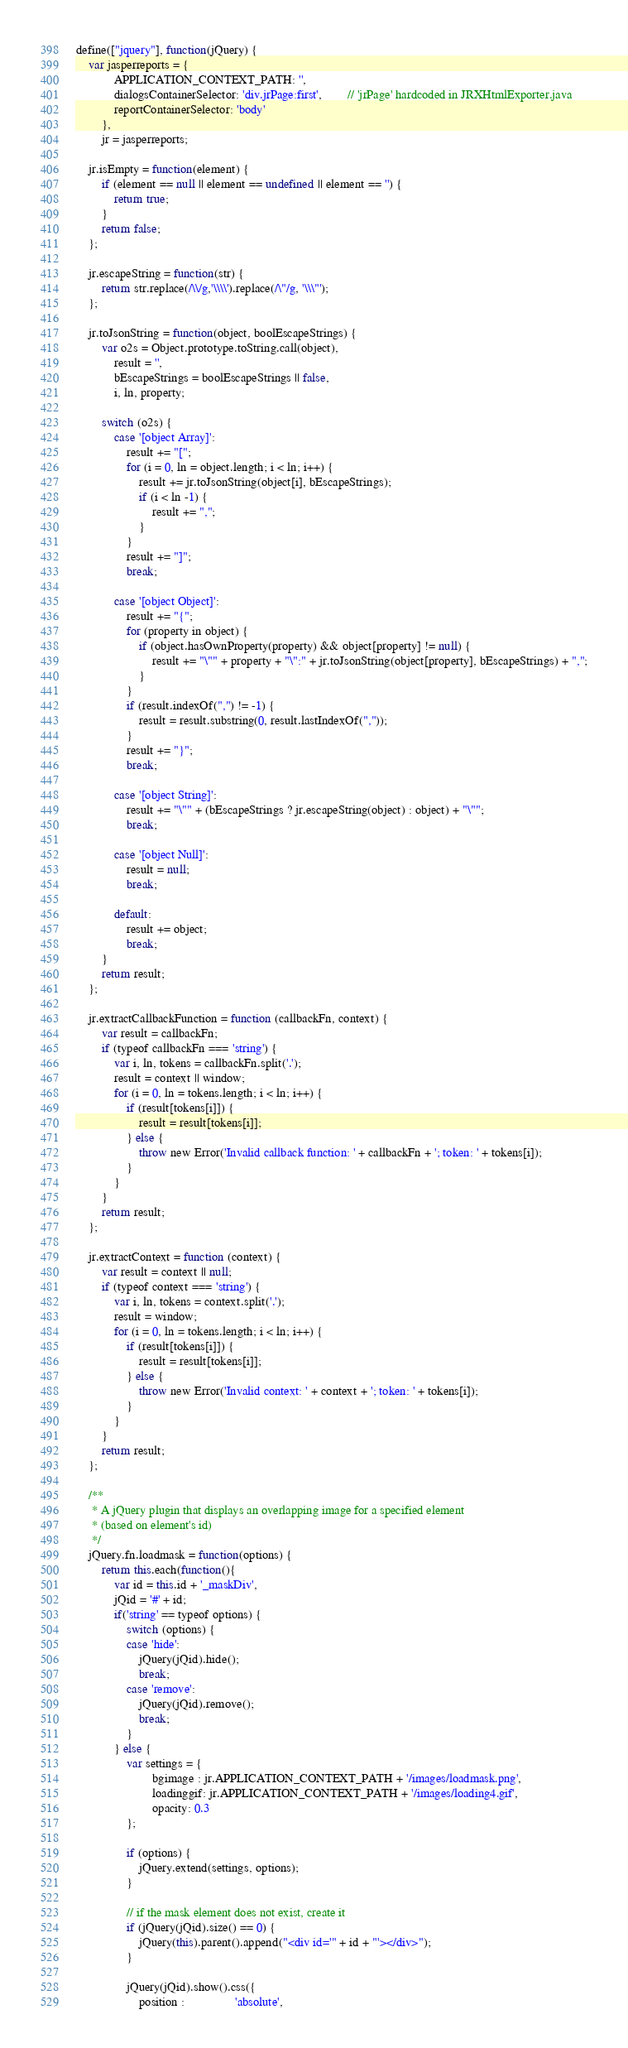Convert code to text. <code><loc_0><loc_0><loc_500><loc_500><_JavaScript_>define(["jquery"], function(jQuery) {
	var jasperreports = {
			APPLICATION_CONTEXT_PATH: '',
			dialogsContainerSelector: 'div.jrPage:first',		// 'jrPage' hardcoded in JRXHtmlExporter.java
			reportContainerSelector: 'body'
		},
		jr = jasperreports;

	jr.isEmpty = function(element) {
		if (element == null || element == undefined || element == '') {
			return true;
		}
		return false;
	};
	
	jr.escapeString = function(str) {
		return str.replace(/\\/g,'\\\\').replace(/\"/g, '\\\"');
	};
	
	jr.toJsonString = function(object, boolEscapeStrings) {
		var o2s = Object.prototype.toString.call(object),
			result = '',
			bEscapeStrings = boolEscapeStrings || false,
			i, ln, property;

		switch (o2s) {
			case '[object Array]':
				result += "[";
				for (i = 0, ln = object.length; i < ln; i++) {
					result += jr.toJsonString(object[i], bEscapeStrings);
					if (i < ln -1) {
						result += ",";
					}
				}
				result += "]";
				break;

			case '[object Object]':
				result += "{";
				for (property in object) {
					if (object.hasOwnProperty(property) && object[property] != null) {
						result += "\"" + property + "\":" + jr.toJsonString(object[property], bEscapeStrings) + ",";
					}
				}
				if (result.indexOf(",") != -1) {
					result = result.substring(0, result.lastIndexOf(","));
				}
				result += "}";
				break;

			case '[object String]':
				result += "\"" + (bEscapeStrings ? jr.escapeString(object) : object) + "\"";
				break;

			case '[object Null]':
				result = null;
				break;

			default:
				result += object;
				break;
		}
		return result;
	};
	
	jr.extractCallbackFunction = function (callbackFn, context) {
		var result = callbackFn;
		if (typeof callbackFn === 'string') {
			var i, ln, tokens = callbackFn.split('.');
			result = context || window;
			for (i = 0, ln = tokens.length; i < ln; i++) {
				if (result[tokens[i]]) {
					result = result[tokens[i]];
				} else {
					throw new Error('Invalid callback function: ' + callbackFn + '; token: ' + tokens[i]);
				}
			}
		}
		return result;
	};
	
	jr.extractContext = function (context) {
		var result = context || null;
		if (typeof context === 'string') {
			var i, ln, tokens = context.split('.');
			result = window;
			for (i = 0, ln = tokens.length; i < ln; i++) {
				if (result[tokens[i]]) {
					result = result[tokens[i]];
				} else {
					throw new Error('Invalid context: ' + context + '; token: ' + tokens[i]);
				}
			}
		}
		return result;
	};

	/**
	 * A jQuery plugin that displays an overlapping image for a specified element 
	 * (based on element's id)
	 */
	jQuery.fn.loadmask = function(options) {
		return this.each(function(){
			var id = this.id + '_maskDiv',
			jQid = '#' + id;
			if('string' == typeof options) {
				switch (options) {
				case 'hide':
					jQuery(jQid).hide();
					break;
				case 'remove':
					jQuery(jQid).remove();
					break;
				}
			} else {
				var settings = {
						bgimage : jr.APPLICATION_CONTEXT_PATH + '/images/loadmask.png',
						loadinggif: jr.APPLICATION_CONTEXT_PATH + '/images/loading4.gif',
						opacity: 0.3
				};
				
				if (options) {
					jQuery.extend(settings, options);
				}
				
				// if the mask element does not exist, create it
				if (jQuery(jQid).size() == 0) {
					jQuery(this).parent().append("<div id='" + id + "'></div>");
				}
				
				jQuery(jQid).show().css({
					position :				'absolute',</code> 